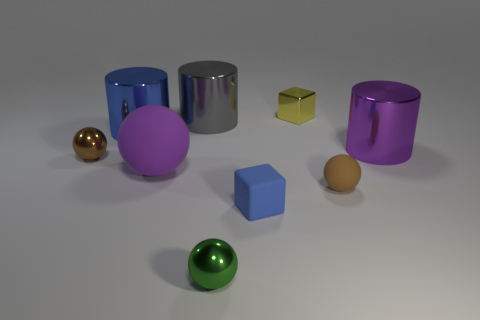There is a large blue thing; what shape is it?
Offer a terse response. Cylinder. How many other things are there of the same shape as the tiny brown metal thing?
Provide a short and direct response. 3. The small metallic object in front of the blue matte thing is what color?
Provide a succinct answer. Green. Are the big purple cylinder and the large purple ball made of the same material?
Your response must be concise. No. What number of things are either large objects or objects behind the brown shiny object?
Offer a terse response. 5. There is a cylinder that is the same color as the big matte thing; what is its size?
Offer a terse response. Large. There is a blue thing that is behind the small blue cube; what is its shape?
Provide a short and direct response. Cylinder. Is the color of the big shiny object on the right side of the small brown rubber object the same as the large matte ball?
Your response must be concise. Yes. There is a large object that is the same color as the large ball; what is it made of?
Your answer should be very brief. Metal. Is the size of the shiny sphere in front of the blue matte object the same as the gray metallic cylinder?
Your answer should be very brief. No. 